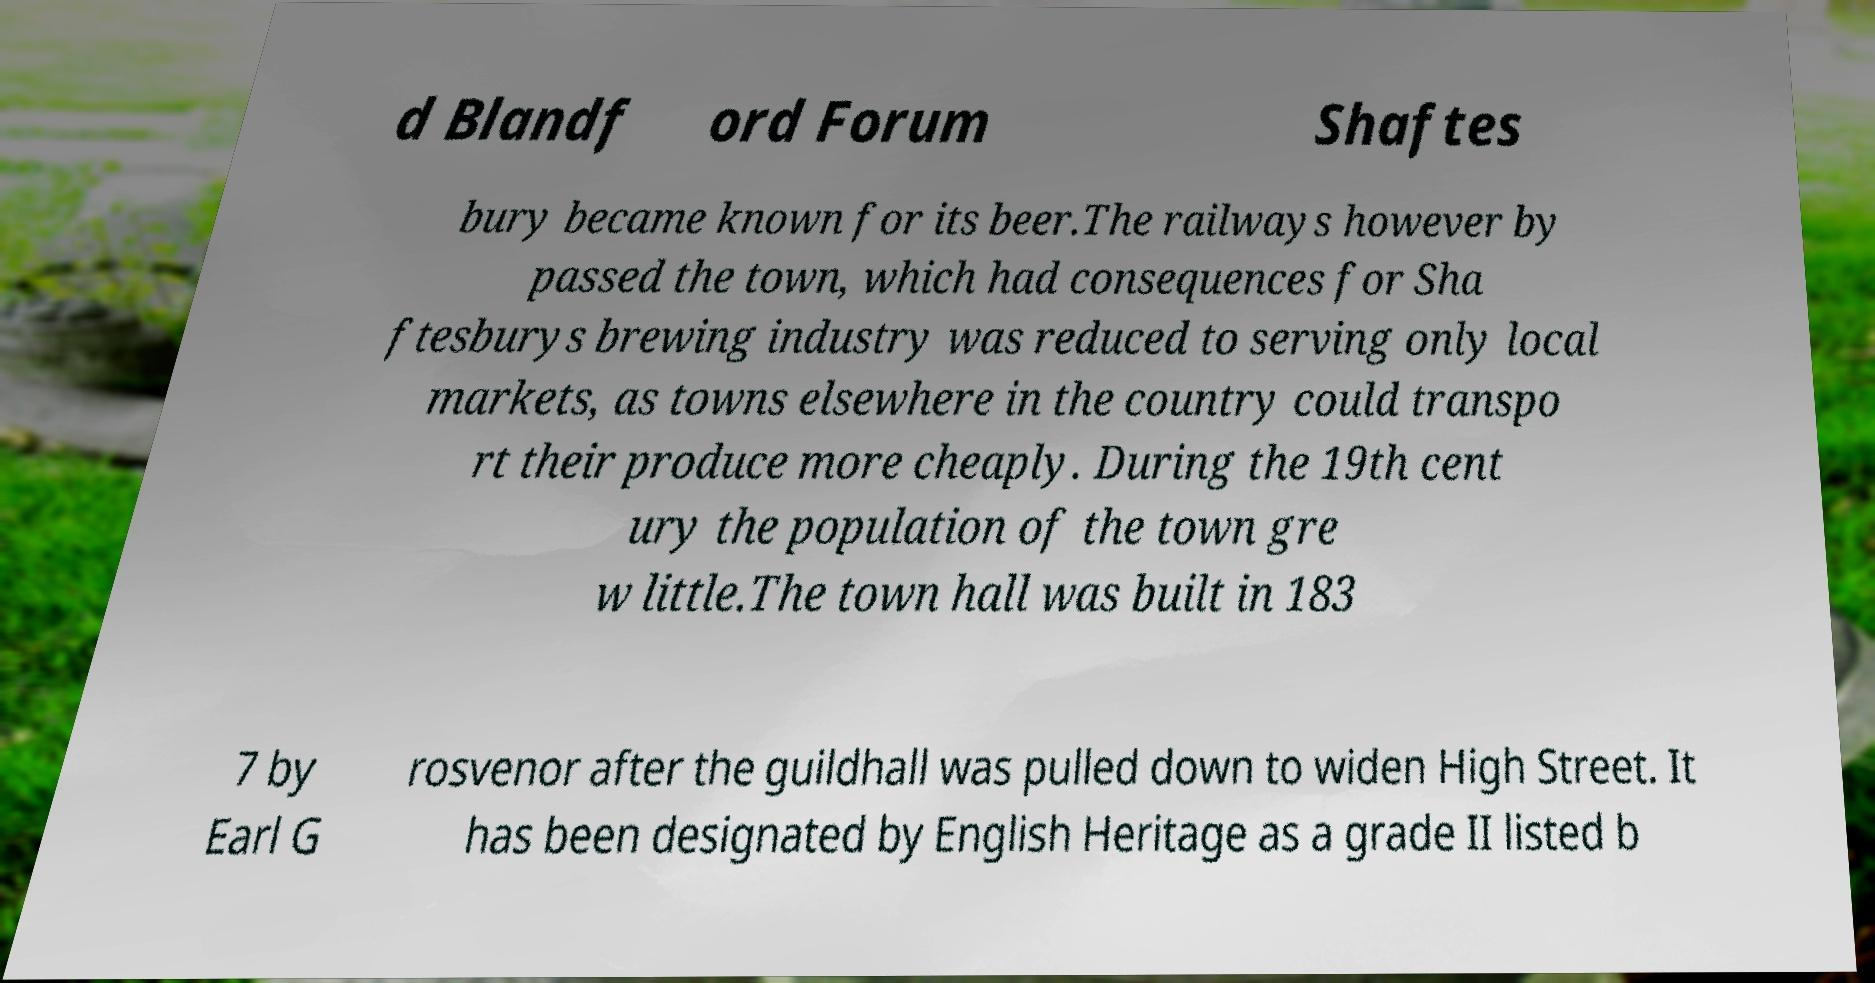Could you extract and type out the text from this image? d Blandf ord Forum Shaftes bury became known for its beer.The railways however by passed the town, which had consequences for Sha ftesburys brewing industry was reduced to serving only local markets, as towns elsewhere in the country could transpo rt their produce more cheaply. During the 19th cent ury the population of the town gre w little.The town hall was built in 183 7 by Earl G rosvenor after the guildhall was pulled down to widen High Street. It has been designated by English Heritage as a grade II listed b 